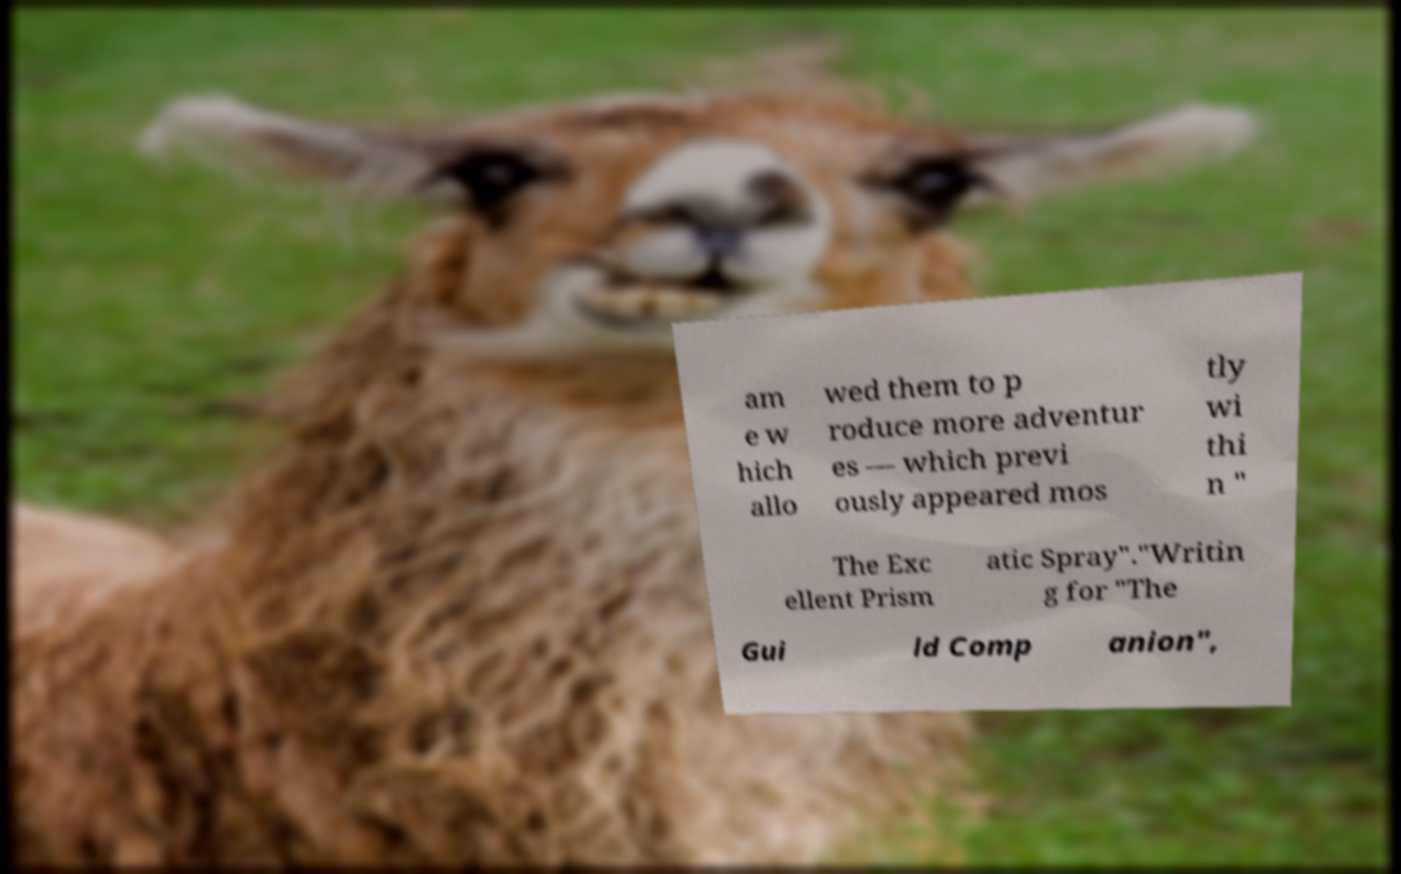There's text embedded in this image that I need extracted. Can you transcribe it verbatim? am e w hich allo wed them to p roduce more adventur es — which previ ously appeared mos tly wi thi n " The Exc ellent Prism atic Spray"."Writin g for "The Gui ld Comp anion", 